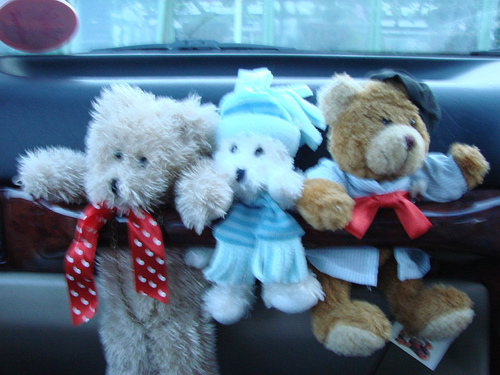<image>
Is the hat on the bear? No. The hat is not positioned on the bear. They may be near each other, but the hat is not supported by or resting on top of the bear. 